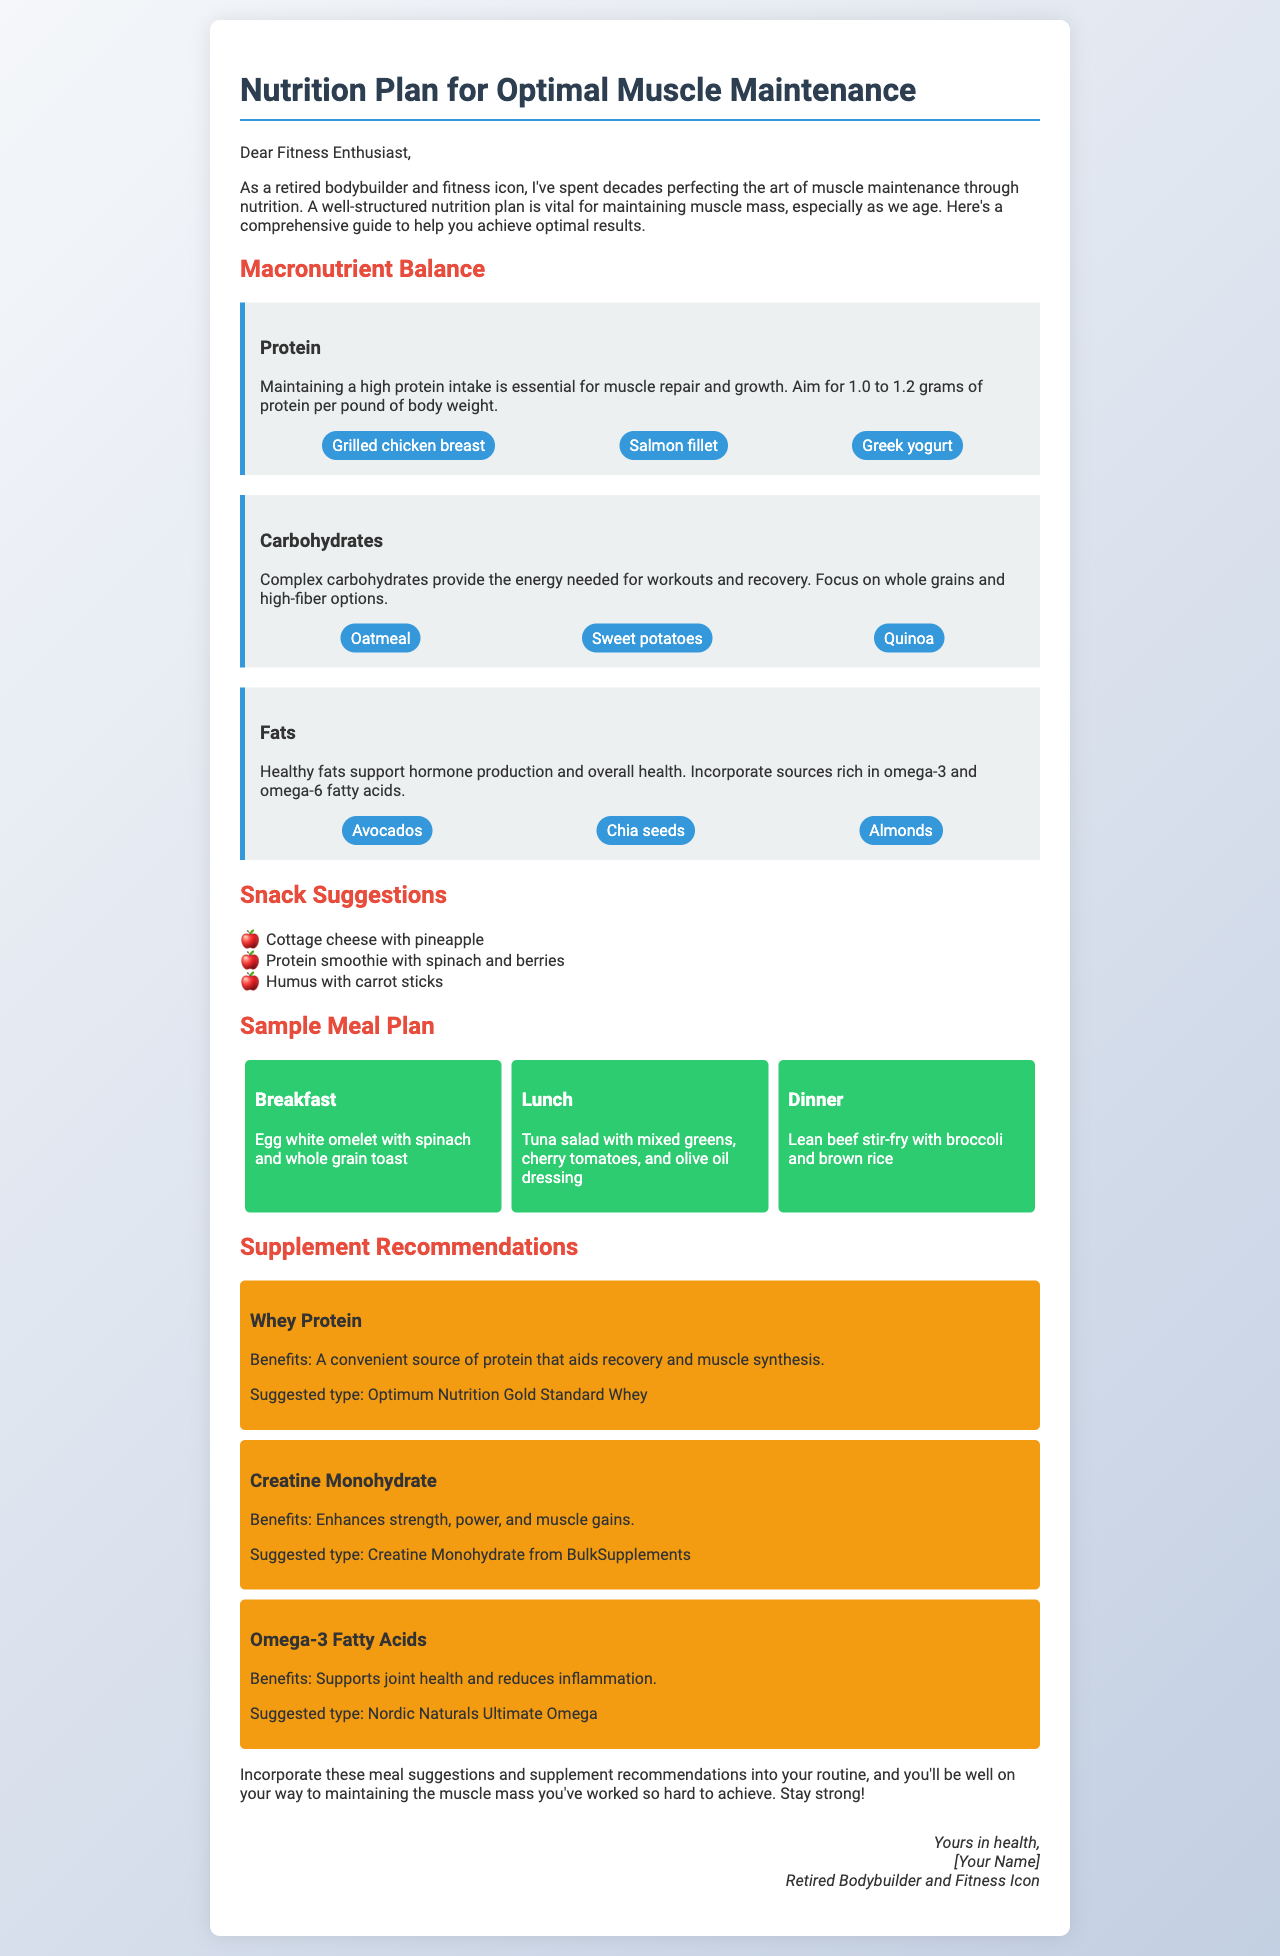What is the primary macronutrient for muscle repair? The document states that maintaining a high protein intake is essential for muscle repair and growth.
Answer: Protein What is the recommended protein intake per pound of body weight? The document advises aiming for 1.0 to 1.2 grams of protein per pound of body weight.
Answer: 1.0 to 1.2 grams Name a snack suggestion given in the document. The document provides snack suggestions such as cottage cheese with pineapple.
Answer: Cottage cheese with pineapple What is included in the breakfast meal suggestion? The document specifies that breakfast includes an egg white omelet with spinach and whole grain toast.
Answer: Egg white omelet with spinach and whole grain toast What benefit does Whey Protein provide according to the recommendations? The document states that Whey Protein is a convenient source of protein that aids recovery and muscle synthesis.
Answer: Aids recovery and muscle synthesis Which food source is suggested for healthy fats? The document recommends avocados as a source of healthy fats.
Answer: Avocados How many types of supplements are mentioned in the document? The document mentions three types of supplements: Whey Protein, Creatine Monohydrate, and Omega-3 Fatty Acids.
Answer: Three What is a source of carbohydrates recommended in the document? The document lists oatmeal as a source of carbohydrates.
Answer: Oatmeal Who is the author of the letter? The document is signed by a retired bodybuilder and fitness icon, which suggests the author is a bodybuilder.
Answer: [Your Name] 